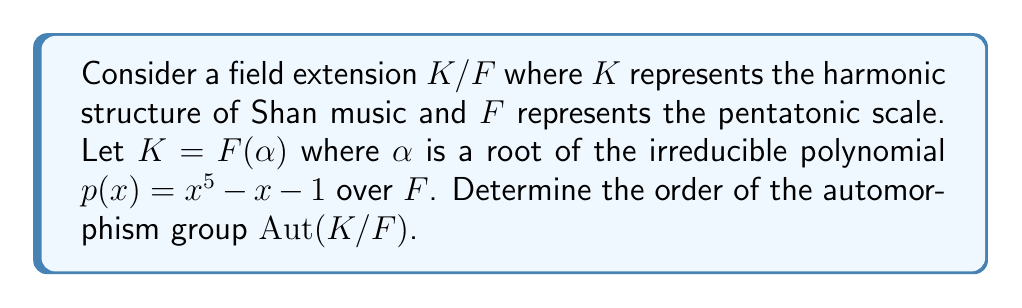Give your solution to this math problem. To solve this problem, we'll follow these steps:

1) First, recall that for a finite separable extension $K/F$, the order of the automorphism group $Aut(K/F)$ is equal to the degree of the extension $[K:F]$.

2) In this case, $K = F(\alpha)$ where $\alpha$ is a root of $p(x) = x^5 - x - 1$. The degree of the extension $[K:F]$ is equal to the degree of the minimal polynomial of $\alpha$ over $F$.

3) We're given that $p(x)$ is irreducible over $F$. Therefore, $p(x)$ is the minimal polynomial of $\alpha$ over $F$.

4) The degree of $p(x)$ is 5.

5) Thus, $[K:F] = 5$.

6) Since $K/F$ is a finite extension (it's algebraic and of finite degree), and the characteristic of $F$ doesn't divide the degree of the extension (assuming char$(F) \neq 5$), the extension is separable.

7) Therefore, $|Aut(K/F)| = [K:F] = 5$.

This result mirrors the five-tone structure common in Shan music, reflecting how mathematical structures can represent musical concepts.
Answer: $|Aut(K/F)| = 5$ 